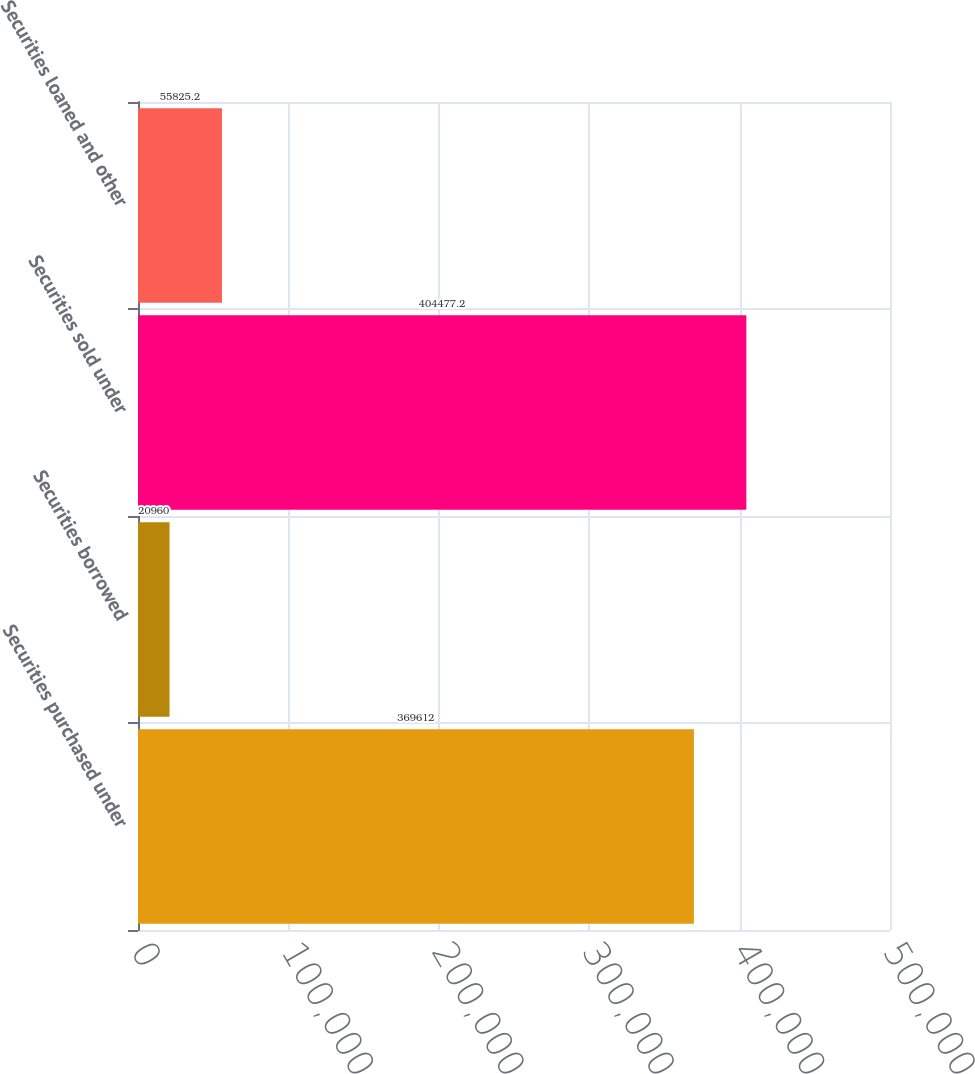<chart> <loc_0><loc_0><loc_500><loc_500><bar_chart><fcel>Securities purchased under<fcel>Securities borrowed<fcel>Securities sold under<fcel>Securities loaned and other<nl><fcel>369612<fcel>20960<fcel>404477<fcel>55825.2<nl></chart> 